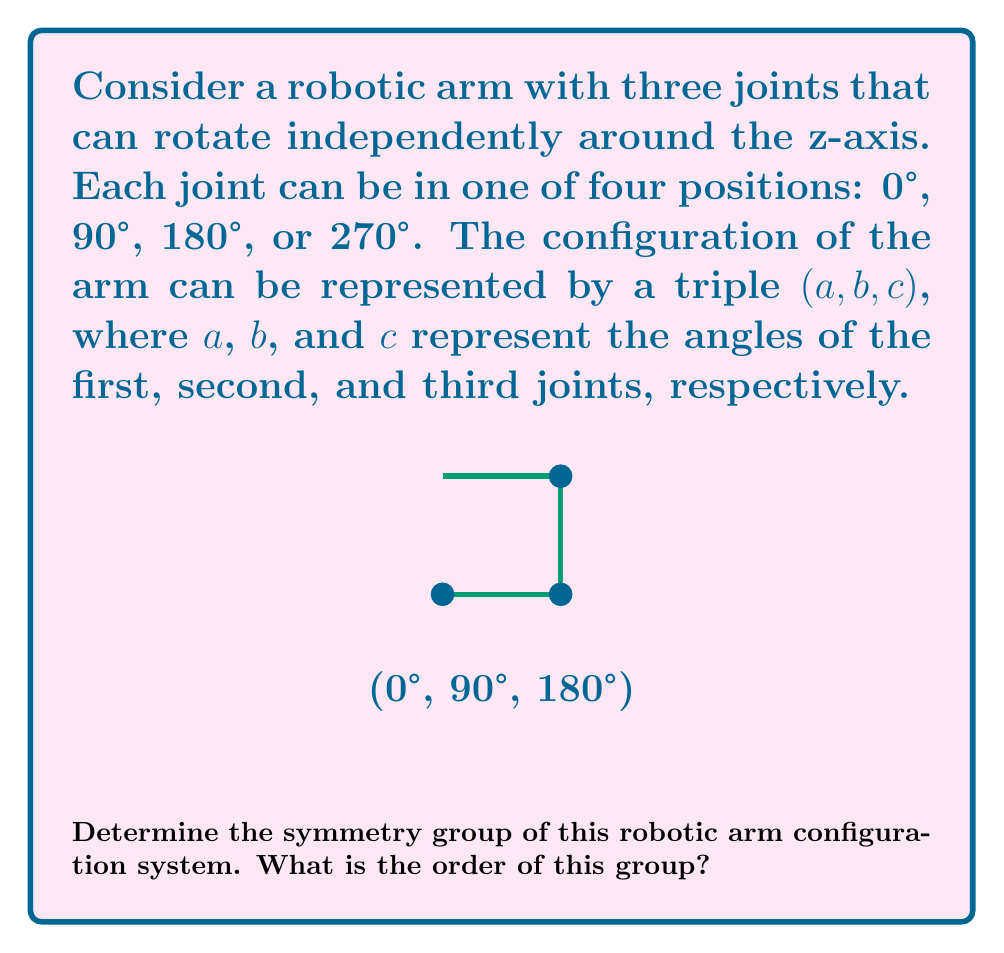What is the answer to this math problem? To determine the symmetry group of this robotic arm configuration, let's follow these steps:

1) First, we need to identify the possible symmetries:
   - Each joint can be in 4 positions (0°, 90°, 180°, 270°)
   - There are 3 joints
   - The total number of possible configurations is $4^3 = 64$

2) The symmetry operations that preserve the structure of this system are:
   - Identity: $(a, b, c) \rightarrow (a, b, c)$
   - Rotation of all joints by 90°: $(a, b, c) \rightarrow ((a+90)\mod 360, (b+90)\mod 360, (c+90)\mod 360)$
   - Rotation of all joints by 180°: $(a, b, c) \rightarrow ((a+180)\mod 360, (b+180)\mod 360, (c+180)\mod 360)$
   - Rotation of all joints by 270°: $(a, b, c) \rightarrow ((a+270)\mod 360, (b+270)\mod 360, (c+270)\mod 360)$

3) These operations form a cyclic group of order 4. We can verify this:
   - The operation is associative
   - The identity element exists
   - Each element has an inverse
   - The group is closed under the operation

4) This group is isomorphic to the cyclic group $C_4$ or $\mathbb{Z}/4\mathbb{Z}$

5) The order of a cyclic group is equal to the number of elements in the group. In this case, there are 4 elements (the identity and the three rotations).

Therefore, the symmetry group of this robotic arm configuration system is the cyclic group of order 4.
Answer: $C_4$ (or $\mathbb{Z}/4\mathbb{Z}$), order 4 